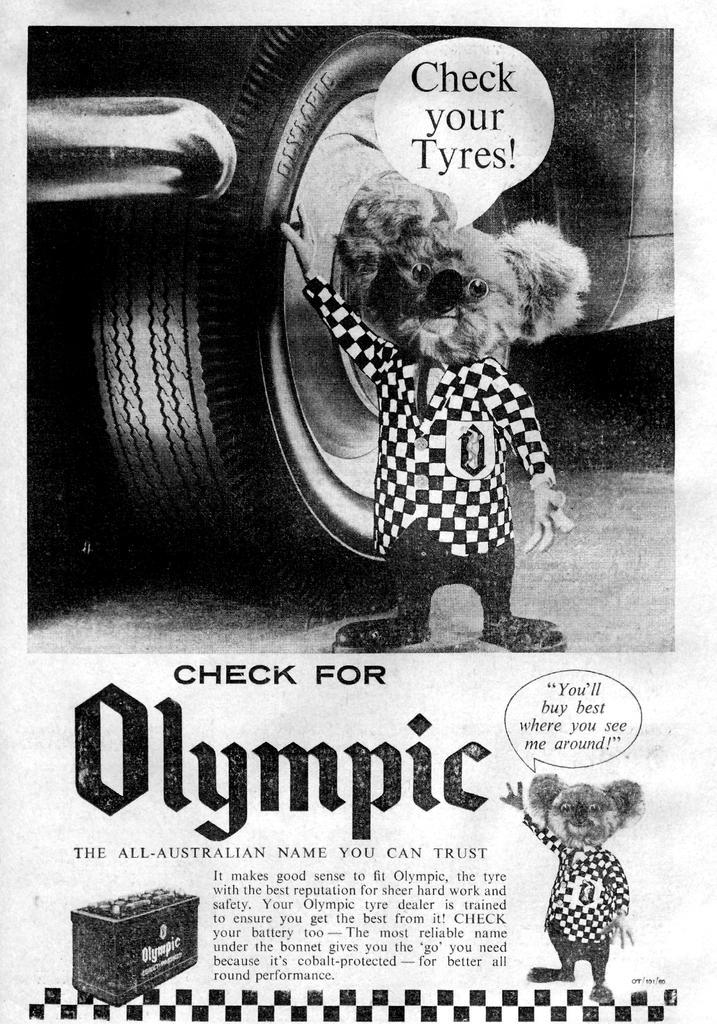How would you summarize this image in a sentence or two? In this image we can see a black and white picture of a car parked on the road, a doll placed on the ground. In the background, we can see some text and a box. 